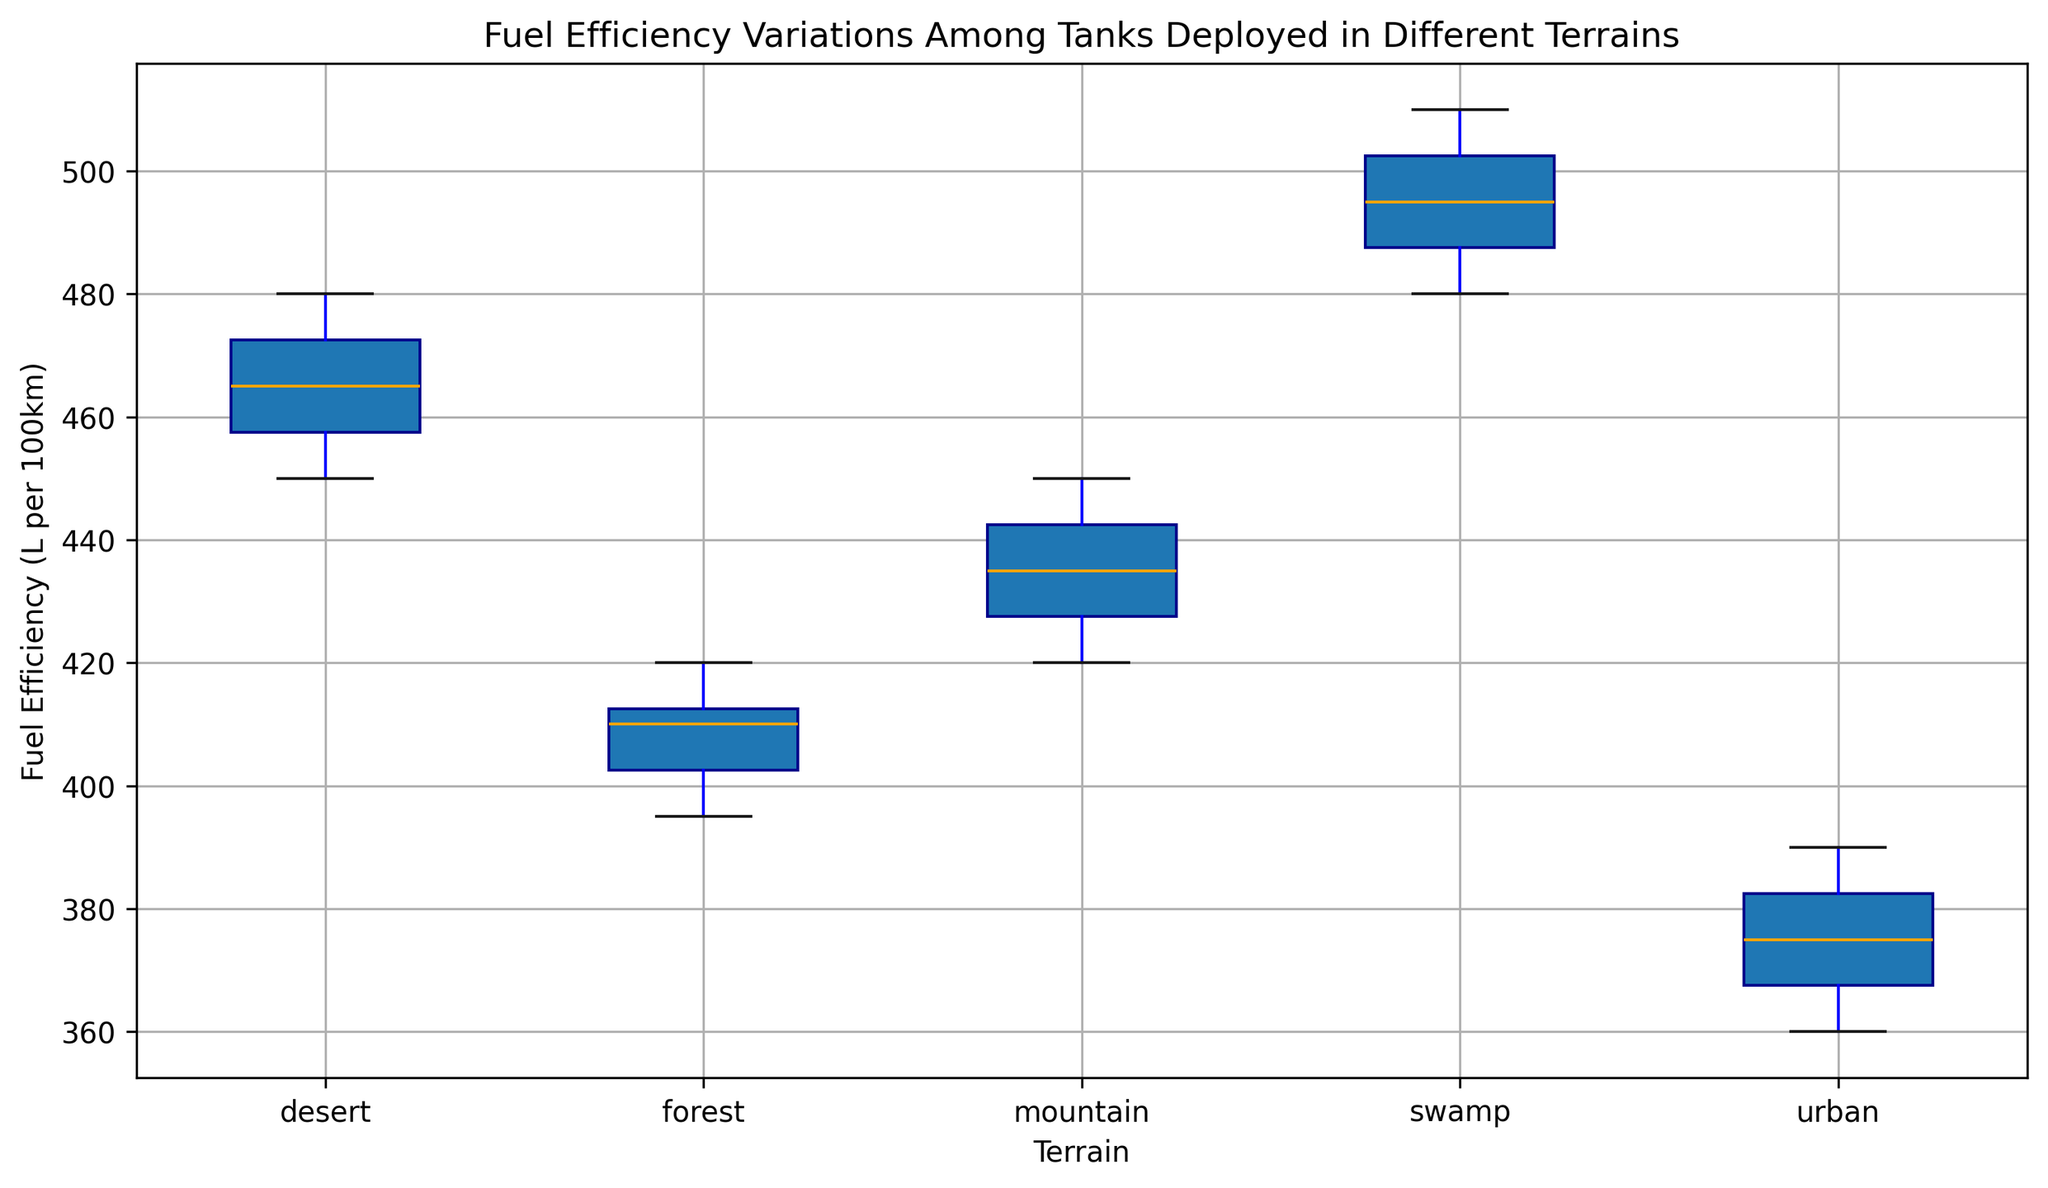Which terrain shows tanks consuming the most fuel on average? The box plot shows the central tendencies (medians) and dispersion of fuel efficiencies for each terrain. The swamp terrain has the highest median value, indicating that tanks consume the most fuel on average in swamp terrain.
Answer: Swamp Which terrain has the widest range of fuel efficiency values? By observing the length of the whiskers and the overall box for each terrain, the desert terrain shows the widest range, indicating the largest variation in fuel efficiency.
Answer: Desert What's the difference in median fuel efficiency between tanks deployed in forest and urban terrains? To find the difference, locate the median lines for forest and urban. The forest median is around 410 L/100km, and the urban median is around 375 L/100km. The difference is 410 - 375 = 35 L/100km.
Answer: 35 L/100km Which terrain has the smallest interquartile range (IQR) for fuel efficiency? The IQR can be determined by the width of the colored box for each terrain. The urban terrain has the smallest IQR, indicating the least variability in the middle 50% of the data.
Answer: Urban Are there any outliers in the fuel efficiency data for desert terrain? Outliers are typically marked by small circles or other symbols. For desert terrain, there are no points outside the whiskers, indicating no outliers.
Answer: No How does fuel efficiency compare between mountain and urban terrains? Compare the median lines and the spread of the boxplots for these two terrains. The median fuel efficiency for tanks in mountain terrains is higher than that in urban terrains, and the variability in mountain terrains is also greater.
Answer: Greater in mountain What's the median fuel efficiency in the terrain with the highest variability? The desert terrain has the highest variability, as seen from its wide range. The median value for desert terrain is approximately 465 L/100km.
Answer: 465 L/100km Which terrain shows the smallest median fuel consumption? The median is represented by the line within the box. The urban terrain has the lowest median fuel consumption at around 375 L/100km.
Answer: Urban Is there a significant overlap in the fuel efficiency ranges of forest and mountain terrains? The boxes and whiskers for the forest and mountain terrains overlap significantly, indicating that their ranges of fuel efficiency values are quite similar.
Answer: Yes Compare the range of fuel efficiency values for swamp and forest terrains. The range for swamp terrain (measured by the distance between the minimum and maximum whiskers) is larger than that for forest terrain, indicating greater variability in swamp terrains.
Answer: Larger in swamp 